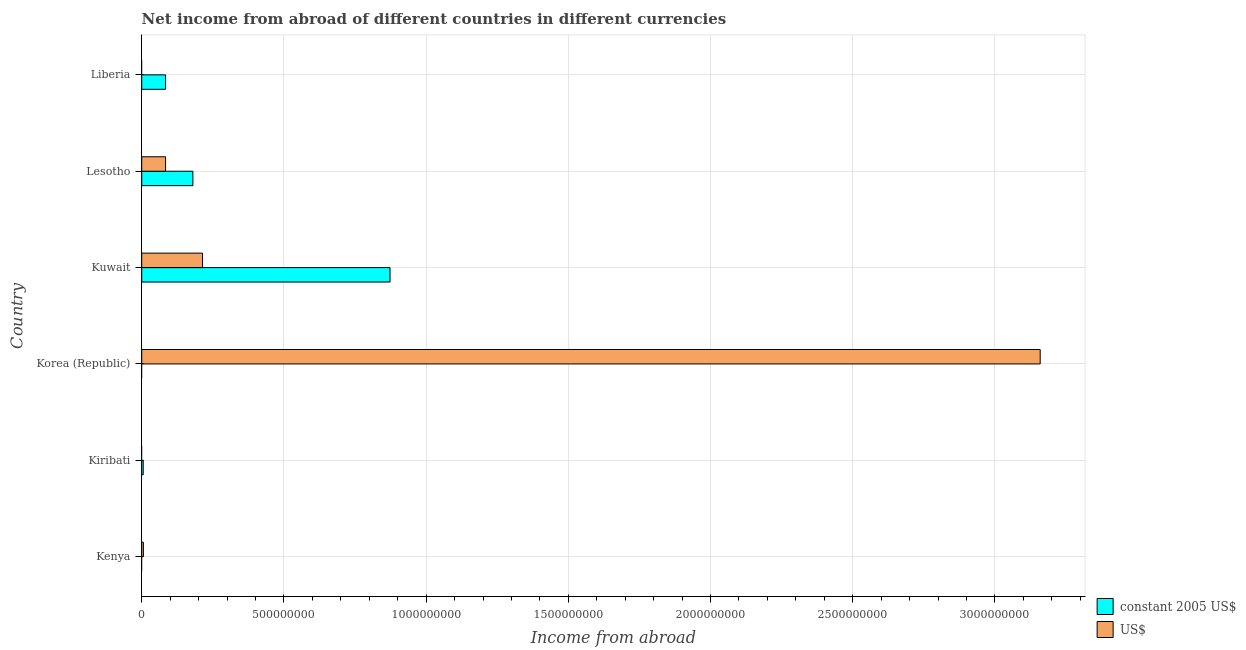How many different coloured bars are there?
Keep it short and to the point. 2. Are the number of bars on each tick of the Y-axis equal?
Offer a terse response. No. How many bars are there on the 3rd tick from the bottom?
Provide a short and direct response. 1. What is the label of the 5th group of bars from the top?
Give a very brief answer. Kiribati. In how many cases, is the number of bars for a given country not equal to the number of legend labels?
Provide a succinct answer. 4. What is the income from abroad in constant 2005 us$ in Lesotho?
Ensure brevity in your answer.  1.80e+08. Across all countries, what is the maximum income from abroad in constant 2005 us$?
Provide a short and direct response. 8.73e+08. In which country was the income from abroad in constant 2005 us$ maximum?
Your response must be concise. Kuwait. What is the total income from abroad in constant 2005 us$ in the graph?
Provide a short and direct response. 1.14e+09. What is the difference between the income from abroad in us$ in Korea (Republic) and that in Kuwait?
Offer a very short reply. 2.95e+09. What is the difference between the income from abroad in us$ in Kenya and the income from abroad in constant 2005 us$ in Korea (Republic)?
Your response must be concise. 5.89e+06. What is the average income from abroad in us$ per country?
Provide a succinct answer. 5.77e+08. What is the difference between the income from abroad in constant 2005 us$ and income from abroad in us$ in Kuwait?
Keep it short and to the point. 6.59e+08. What is the ratio of the income from abroad in us$ in Korea (Republic) to that in Kuwait?
Give a very brief answer. 14.79. Is the income from abroad in us$ in Kenya less than that in Kuwait?
Your answer should be very brief. Yes. What is the difference between the highest and the second highest income from abroad in constant 2005 us$?
Offer a terse response. 6.93e+08. What is the difference between the highest and the lowest income from abroad in constant 2005 us$?
Provide a succinct answer. 8.73e+08. In how many countries, is the income from abroad in us$ greater than the average income from abroad in us$ taken over all countries?
Your answer should be very brief. 1. Is the sum of the income from abroad in constant 2005 us$ in Kiribati and Liberia greater than the maximum income from abroad in us$ across all countries?
Make the answer very short. No. What is the difference between two consecutive major ticks on the X-axis?
Keep it short and to the point. 5.00e+08. Does the graph contain any zero values?
Give a very brief answer. Yes. Where does the legend appear in the graph?
Keep it short and to the point. Bottom right. What is the title of the graph?
Provide a succinct answer. Net income from abroad of different countries in different currencies. Does "By country of origin" appear as one of the legend labels in the graph?
Provide a short and direct response. No. What is the label or title of the X-axis?
Your answer should be very brief. Income from abroad. What is the label or title of the Y-axis?
Make the answer very short. Country. What is the Income from abroad of constant 2005 US$ in Kenya?
Offer a very short reply. 0. What is the Income from abroad in US$ in Kenya?
Offer a very short reply. 5.89e+06. What is the Income from abroad in constant 2005 US$ in Kiribati?
Your answer should be very brief. 5.27e+06. What is the Income from abroad in US$ in Kiribati?
Offer a terse response. 0. What is the Income from abroad in US$ in Korea (Republic)?
Give a very brief answer. 3.16e+09. What is the Income from abroad of constant 2005 US$ in Kuwait?
Make the answer very short. 8.73e+08. What is the Income from abroad in US$ in Kuwait?
Your answer should be compact. 2.14e+08. What is the Income from abroad of constant 2005 US$ in Lesotho?
Your response must be concise. 1.80e+08. What is the Income from abroad of US$ in Lesotho?
Ensure brevity in your answer.  8.38e+07. What is the Income from abroad of constant 2005 US$ in Liberia?
Your answer should be compact. 8.38e+07. Across all countries, what is the maximum Income from abroad of constant 2005 US$?
Provide a short and direct response. 8.73e+08. Across all countries, what is the maximum Income from abroad in US$?
Your response must be concise. 3.16e+09. Across all countries, what is the minimum Income from abroad of constant 2005 US$?
Your answer should be very brief. 0. Across all countries, what is the minimum Income from abroad in US$?
Your response must be concise. 0. What is the total Income from abroad of constant 2005 US$ in the graph?
Provide a short and direct response. 1.14e+09. What is the total Income from abroad in US$ in the graph?
Keep it short and to the point. 3.46e+09. What is the difference between the Income from abroad of US$ in Kenya and that in Korea (Republic)?
Give a very brief answer. -3.15e+09. What is the difference between the Income from abroad in US$ in Kenya and that in Kuwait?
Your answer should be compact. -2.08e+08. What is the difference between the Income from abroad of US$ in Kenya and that in Lesotho?
Make the answer very short. -7.79e+07. What is the difference between the Income from abroad of constant 2005 US$ in Kiribati and that in Kuwait?
Offer a terse response. -8.68e+08. What is the difference between the Income from abroad in constant 2005 US$ in Kiribati and that in Lesotho?
Provide a short and direct response. -1.75e+08. What is the difference between the Income from abroad in constant 2005 US$ in Kiribati and that in Liberia?
Offer a very short reply. -7.85e+07. What is the difference between the Income from abroad in US$ in Korea (Republic) and that in Kuwait?
Offer a very short reply. 2.95e+09. What is the difference between the Income from abroad of US$ in Korea (Republic) and that in Lesotho?
Your answer should be very brief. 3.08e+09. What is the difference between the Income from abroad of constant 2005 US$ in Kuwait and that in Lesotho?
Your answer should be compact. 6.93e+08. What is the difference between the Income from abroad of US$ in Kuwait and that in Lesotho?
Your answer should be compact. 1.30e+08. What is the difference between the Income from abroad in constant 2005 US$ in Kuwait and that in Liberia?
Offer a terse response. 7.89e+08. What is the difference between the Income from abroad in constant 2005 US$ in Lesotho and that in Liberia?
Ensure brevity in your answer.  9.61e+07. What is the difference between the Income from abroad of constant 2005 US$ in Kiribati and the Income from abroad of US$ in Korea (Republic)?
Ensure brevity in your answer.  -3.15e+09. What is the difference between the Income from abroad in constant 2005 US$ in Kiribati and the Income from abroad in US$ in Kuwait?
Your answer should be compact. -2.08e+08. What is the difference between the Income from abroad in constant 2005 US$ in Kiribati and the Income from abroad in US$ in Lesotho?
Keep it short and to the point. -7.85e+07. What is the difference between the Income from abroad of constant 2005 US$ in Kuwait and the Income from abroad of US$ in Lesotho?
Your response must be concise. 7.89e+08. What is the average Income from abroad of constant 2005 US$ per country?
Your answer should be very brief. 1.90e+08. What is the average Income from abroad of US$ per country?
Keep it short and to the point. 5.77e+08. What is the difference between the Income from abroad in constant 2005 US$ and Income from abroad in US$ in Kuwait?
Keep it short and to the point. 6.59e+08. What is the difference between the Income from abroad in constant 2005 US$ and Income from abroad in US$ in Lesotho?
Your answer should be compact. 9.61e+07. What is the ratio of the Income from abroad in US$ in Kenya to that in Korea (Republic)?
Keep it short and to the point. 0. What is the ratio of the Income from abroad of US$ in Kenya to that in Kuwait?
Your answer should be compact. 0.03. What is the ratio of the Income from abroad in US$ in Kenya to that in Lesotho?
Give a very brief answer. 0.07. What is the ratio of the Income from abroad in constant 2005 US$ in Kiribati to that in Kuwait?
Offer a very short reply. 0.01. What is the ratio of the Income from abroad in constant 2005 US$ in Kiribati to that in Lesotho?
Provide a succinct answer. 0.03. What is the ratio of the Income from abroad in constant 2005 US$ in Kiribati to that in Liberia?
Give a very brief answer. 0.06. What is the ratio of the Income from abroad of US$ in Korea (Republic) to that in Kuwait?
Your answer should be very brief. 14.79. What is the ratio of the Income from abroad in US$ in Korea (Republic) to that in Lesotho?
Ensure brevity in your answer.  37.69. What is the ratio of the Income from abroad in constant 2005 US$ in Kuwait to that in Lesotho?
Offer a very short reply. 4.85. What is the ratio of the Income from abroad of US$ in Kuwait to that in Lesotho?
Your answer should be very brief. 2.55. What is the ratio of the Income from abroad of constant 2005 US$ in Kuwait to that in Liberia?
Keep it short and to the point. 10.42. What is the ratio of the Income from abroad of constant 2005 US$ in Lesotho to that in Liberia?
Provide a short and direct response. 2.15. What is the difference between the highest and the second highest Income from abroad in constant 2005 US$?
Make the answer very short. 6.93e+08. What is the difference between the highest and the second highest Income from abroad in US$?
Make the answer very short. 2.95e+09. What is the difference between the highest and the lowest Income from abroad in constant 2005 US$?
Your answer should be very brief. 8.73e+08. What is the difference between the highest and the lowest Income from abroad of US$?
Your answer should be very brief. 3.16e+09. 